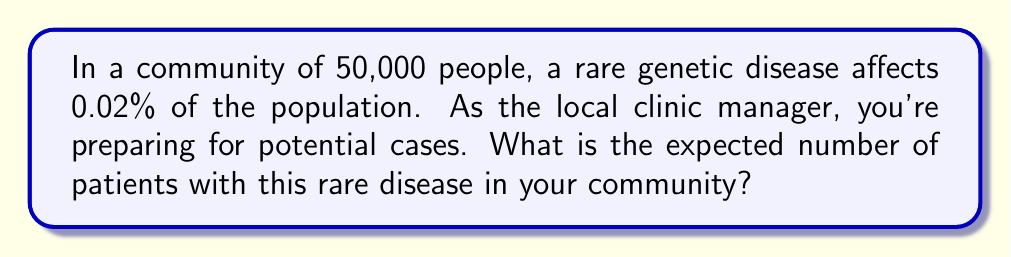Provide a solution to this math problem. To solve this problem, we need to use the concept of expected value in probability theory. The expected value is calculated by multiplying the probability of an event by the total number of possible outcomes.

Step 1: Identify the given information
- Total population: $N = 50,000$
- Probability of having the disease: $p = 0.02\% = 0.0002$

Step 2: Calculate the expected number of patients
The expected number of patients, $E$, is given by:

$$E = N \times p$$

Substituting the values:

$$E = 50,000 \times 0.0002$$

Step 3: Perform the calculation
$$E = 10$$

Therefore, the expected number of patients with the rare genetic disease in the community is 10.
Answer: 10 patients 